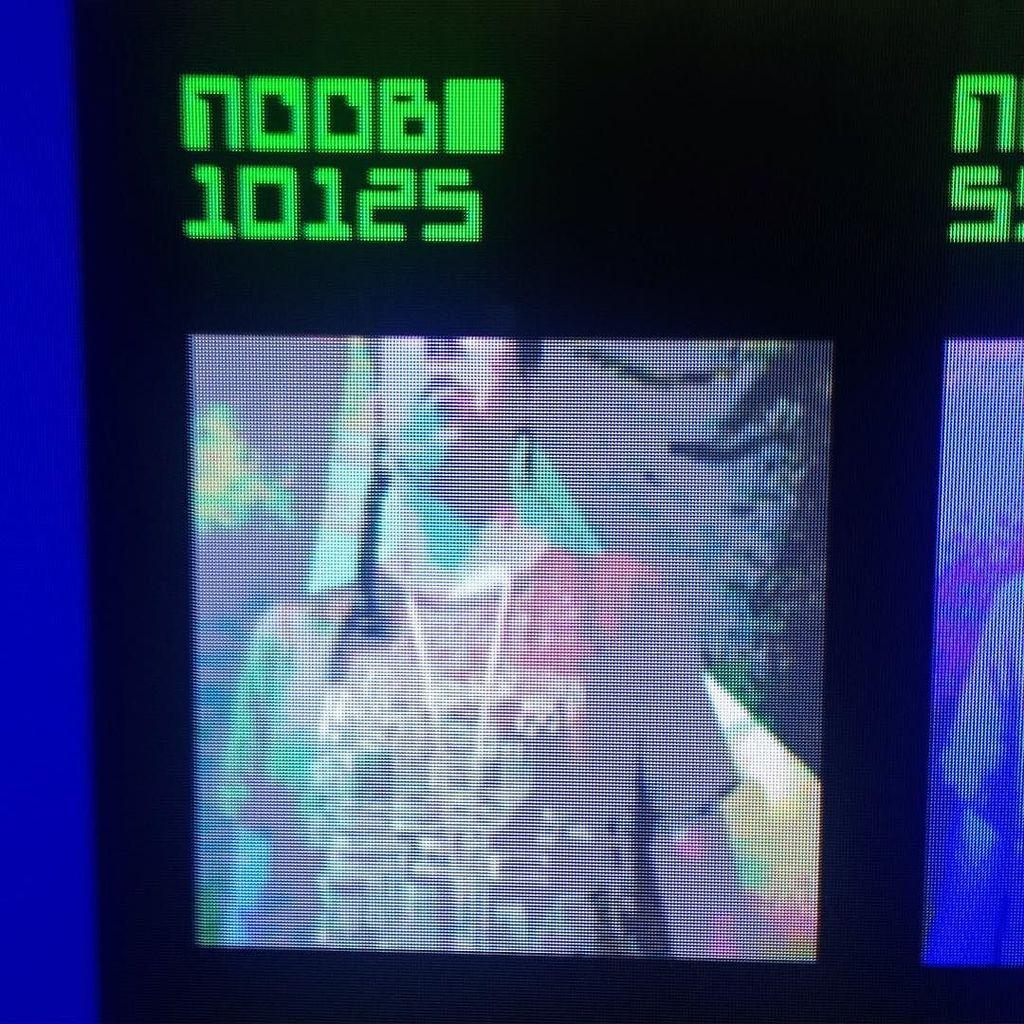What is displayed on the screen in the image? There are pictures visible on a screen in the image. What else can be seen on the screen besides the pictures? There is text visible on the screen in the image. What type of can is being used to fuel the screen in the image? There is no can or fuel present in the image; it features a screen displaying pictures and text. How many beads are visible on the screen in the image? There are no beads visible on the screen in the image. 